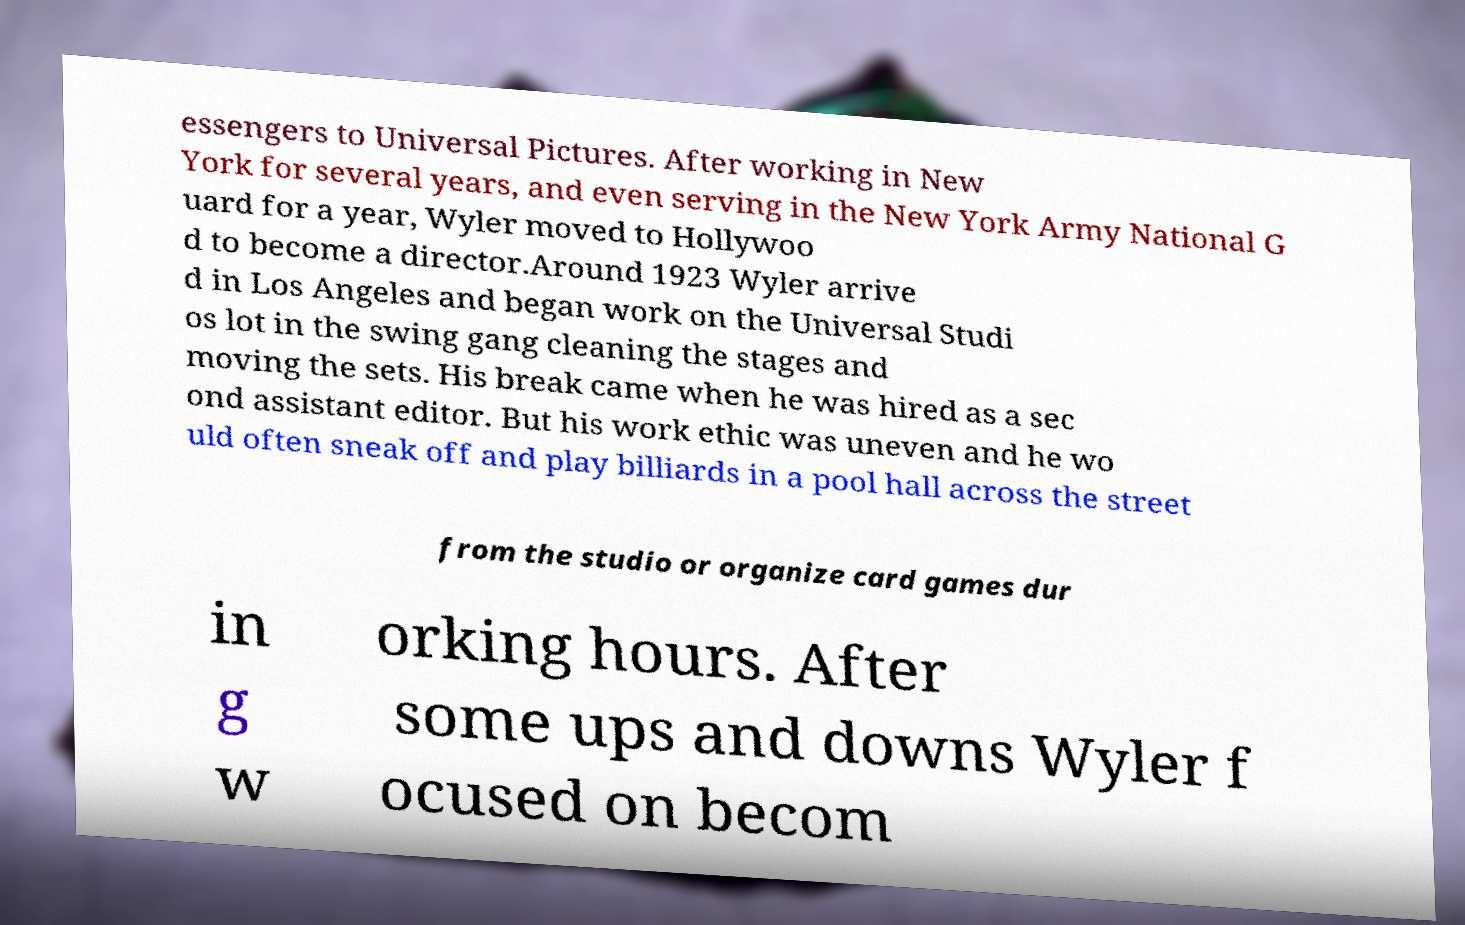Please read and relay the text visible in this image. What does it say? essengers to Universal Pictures. After working in New York for several years, and even serving in the New York Army National G uard for a year, Wyler moved to Hollywoo d to become a director.Around 1923 Wyler arrive d in Los Angeles and began work on the Universal Studi os lot in the swing gang cleaning the stages and moving the sets. His break came when he was hired as a sec ond assistant editor. But his work ethic was uneven and he wo uld often sneak off and play billiards in a pool hall across the street from the studio or organize card games dur in g w orking hours. After some ups and downs Wyler f ocused on becom 